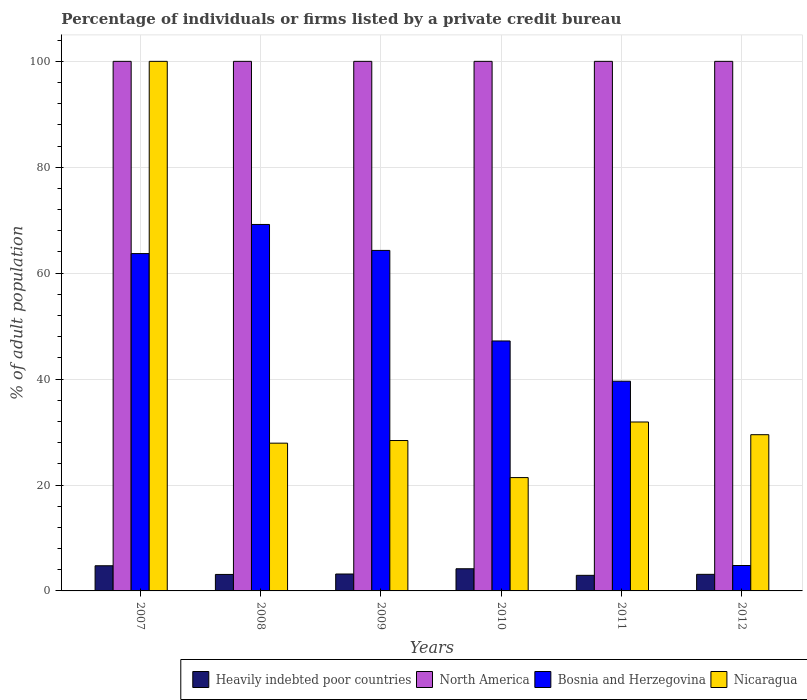Are the number of bars per tick equal to the number of legend labels?
Give a very brief answer. Yes. How many bars are there on the 6th tick from the left?
Your response must be concise. 4. How many bars are there on the 5th tick from the right?
Give a very brief answer. 4. What is the label of the 6th group of bars from the left?
Make the answer very short. 2012. What is the percentage of population listed by a private credit bureau in Bosnia and Herzegovina in 2011?
Your answer should be compact. 39.6. Across all years, what is the maximum percentage of population listed by a private credit bureau in North America?
Provide a succinct answer. 100. Across all years, what is the minimum percentage of population listed by a private credit bureau in North America?
Offer a very short reply. 100. In which year was the percentage of population listed by a private credit bureau in Bosnia and Herzegovina maximum?
Your response must be concise. 2008. What is the total percentage of population listed by a private credit bureau in Heavily indebted poor countries in the graph?
Make the answer very short. 21.32. What is the difference between the percentage of population listed by a private credit bureau in Bosnia and Herzegovina in 2007 and that in 2012?
Give a very brief answer. 58.9. What is the difference between the percentage of population listed by a private credit bureau in Heavily indebted poor countries in 2008 and the percentage of population listed by a private credit bureau in Bosnia and Herzegovina in 2009?
Make the answer very short. -61.19. What is the average percentage of population listed by a private credit bureau in Nicaragua per year?
Make the answer very short. 39.85. In the year 2009, what is the difference between the percentage of population listed by a private credit bureau in Bosnia and Herzegovina and percentage of population listed by a private credit bureau in North America?
Provide a short and direct response. -35.7. What is the ratio of the percentage of population listed by a private credit bureau in Heavily indebted poor countries in 2010 to that in 2011?
Offer a terse response. 1.42. Is the percentage of population listed by a private credit bureau in Heavily indebted poor countries in 2007 less than that in 2011?
Ensure brevity in your answer.  No. What is the difference between the highest and the second highest percentage of population listed by a private credit bureau in Nicaragua?
Your answer should be very brief. 68.1. What is the difference between the highest and the lowest percentage of population listed by a private credit bureau in Bosnia and Herzegovina?
Your answer should be very brief. 64.4. Is the sum of the percentage of population listed by a private credit bureau in Bosnia and Herzegovina in 2007 and 2010 greater than the maximum percentage of population listed by a private credit bureau in North America across all years?
Offer a terse response. Yes. Is it the case that in every year, the sum of the percentage of population listed by a private credit bureau in Nicaragua and percentage of population listed by a private credit bureau in North America is greater than the sum of percentage of population listed by a private credit bureau in Heavily indebted poor countries and percentage of population listed by a private credit bureau in Bosnia and Herzegovina?
Offer a very short reply. No. What does the 4th bar from the left in 2008 represents?
Offer a very short reply. Nicaragua. What does the 2nd bar from the right in 2010 represents?
Your answer should be very brief. Bosnia and Herzegovina. How many bars are there?
Keep it short and to the point. 24. Are all the bars in the graph horizontal?
Make the answer very short. No. How many years are there in the graph?
Provide a succinct answer. 6. What is the difference between two consecutive major ticks on the Y-axis?
Keep it short and to the point. 20. How many legend labels are there?
Your response must be concise. 4. How are the legend labels stacked?
Make the answer very short. Horizontal. What is the title of the graph?
Make the answer very short. Percentage of individuals or firms listed by a private credit bureau. What is the label or title of the X-axis?
Make the answer very short. Years. What is the label or title of the Y-axis?
Make the answer very short. % of adult population. What is the % of adult population in Heavily indebted poor countries in 2007?
Provide a short and direct response. 4.75. What is the % of adult population of Bosnia and Herzegovina in 2007?
Your response must be concise. 63.7. What is the % of adult population in Nicaragua in 2007?
Make the answer very short. 100. What is the % of adult population of Heavily indebted poor countries in 2008?
Ensure brevity in your answer.  3.11. What is the % of adult population of North America in 2008?
Make the answer very short. 100. What is the % of adult population of Bosnia and Herzegovina in 2008?
Offer a terse response. 69.2. What is the % of adult population of Nicaragua in 2008?
Make the answer very short. 27.9. What is the % of adult population in Heavily indebted poor countries in 2009?
Your response must be concise. 3.19. What is the % of adult population of North America in 2009?
Keep it short and to the point. 100. What is the % of adult population in Bosnia and Herzegovina in 2009?
Give a very brief answer. 64.3. What is the % of adult population in Nicaragua in 2009?
Ensure brevity in your answer.  28.4. What is the % of adult population of Heavily indebted poor countries in 2010?
Provide a short and direct response. 4.18. What is the % of adult population of Bosnia and Herzegovina in 2010?
Your answer should be compact. 47.2. What is the % of adult population in Nicaragua in 2010?
Provide a succinct answer. 21.4. What is the % of adult population of Heavily indebted poor countries in 2011?
Your answer should be very brief. 2.94. What is the % of adult population of North America in 2011?
Ensure brevity in your answer.  100. What is the % of adult population of Bosnia and Herzegovina in 2011?
Provide a succinct answer. 39.6. What is the % of adult population of Nicaragua in 2011?
Your response must be concise. 31.9. What is the % of adult population in Heavily indebted poor countries in 2012?
Provide a short and direct response. 3.13. What is the % of adult population in Bosnia and Herzegovina in 2012?
Give a very brief answer. 4.8. What is the % of adult population in Nicaragua in 2012?
Make the answer very short. 29.5. Across all years, what is the maximum % of adult population of Heavily indebted poor countries?
Keep it short and to the point. 4.75. Across all years, what is the maximum % of adult population in Bosnia and Herzegovina?
Offer a terse response. 69.2. Across all years, what is the maximum % of adult population in Nicaragua?
Your answer should be very brief. 100. Across all years, what is the minimum % of adult population in Heavily indebted poor countries?
Your response must be concise. 2.94. Across all years, what is the minimum % of adult population of Bosnia and Herzegovina?
Offer a very short reply. 4.8. Across all years, what is the minimum % of adult population of Nicaragua?
Offer a terse response. 21.4. What is the total % of adult population of Heavily indebted poor countries in the graph?
Make the answer very short. 21.32. What is the total % of adult population in North America in the graph?
Ensure brevity in your answer.  600. What is the total % of adult population of Bosnia and Herzegovina in the graph?
Provide a succinct answer. 288.8. What is the total % of adult population of Nicaragua in the graph?
Your answer should be compact. 239.1. What is the difference between the % of adult population of Heavily indebted poor countries in 2007 and that in 2008?
Make the answer very short. 1.64. What is the difference between the % of adult population of Bosnia and Herzegovina in 2007 and that in 2008?
Your response must be concise. -5.5. What is the difference between the % of adult population of Nicaragua in 2007 and that in 2008?
Keep it short and to the point. 72.1. What is the difference between the % of adult population in Heavily indebted poor countries in 2007 and that in 2009?
Your answer should be compact. 1.56. What is the difference between the % of adult population in Nicaragua in 2007 and that in 2009?
Your answer should be compact. 71.6. What is the difference between the % of adult population of Heavily indebted poor countries in 2007 and that in 2010?
Ensure brevity in your answer.  0.57. What is the difference between the % of adult population of North America in 2007 and that in 2010?
Provide a short and direct response. 0. What is the difference between the % of adult population in Bosnia and Herzegovina in 2007 and that in 2010?
Your answer should be very brief. 16.5. What is the difference between the % of adult population of Nicaragua in 2007 and that in 2010?
Your answer should be very brief. 78.6. What is the difference between the % of adult population in Heavily indebted poor countries in 2007 and that in 2011?
Offer a very short reply. 1.81. What is the difference between the % of adult population in North America in 2007 and that in 2011?
Give a very brief answer. 0. What is the difference between the % of adult population of Bosnia and Herzegovina in 2007 and that in 2011?
Offer a terse response. 24.1. What is the difference between the % of adult population of Nicaragua in 2007 and that in 2011?
Make the answer very short. 68.1. What is the difference between the % of adult population in Heavily indebted poor countries in 2007 and that in 2012?
Your response must be concise. 1.62. What is the difference between the % of adult population in Bosnia and Herzegovina in 2007 and that in 2012?
Your answer should be very brief. 58.9. What is the difference between the % of adult population of Nicaragua in 2007 and that in 2012?
Your answer should be compact. 70.5. What is the difference between the % of adult population in Heavily indebted poor countries in 2008 and that in 2009?
Provide a short and direct response. -0.08. What is the difference between the % of adult population in North America in 2008 and that in 2009?
Your answer should be very brief. 0. What is the difference between the % of adult population of Nicaragua in 2008 and that in 2009?
Give a very brief answer. -0.5. What is the difference between the % of adult population in Heavily indebted poor countries in 2008 and that in 2010?
Your answer should be very brief. -1.07. What is the difference between the % of adult population in Bosnia and Herzegovina in 2008 and that in 2010?
Keep it short and to the point. 22. What is the difference between the % of adult population in Heavily indebted poor countries in 2008 and that in 2011?
Provide a short and direct response. 0.17. What is the difference between the % of adult population in North America in 2008 and that in 2011?
Offer a very short reply. 0. What is the difference between the % of adult population of Bosnia and Herzegovina in 2008 and that in 2011?
Offer a very short reply. 29.6. What is the difference between the % of adult population of Nicaragua in 2008 and that in 2011?
Offer a terse response. -4. What is the difference between the % of adult population of Heavily indebted poor countries in 2008 and that in 2012?
Your answer should be very brief. -0.02. What is the difference between the % of adult population of North America in 2008 and that in 2012?
Your answer should be very brief. 0. What is the difference between the % of adult population in Bosnia and Herzegovina in 2008 and that in 2012?
Make the answer very short. 64.4. What is the difference between the % of adult population in Heavily indebted poor countries in 2009 and that in 2010?
Your answer should be compact. -0.99. What is the difference between the % of adult population of Bosnia and Herzegovina in 2009 and that in 2010?
Provide a short and direct response. 17.1. What is the difference between the % of adult population in Nicaragua in 2009 and that in 2010?
Your answer should be very brief. 7. What is the difference between the % of adult population in Heavily indebted poor countries in 2009 and that in 2011?
Offer a very short reply. 0.25. What is the difference between the % of adult population of Bosnia and Herzegovina in 2009 and that in 2011?
Your answer should be very brief. 24.7. What is the difference between the % of adult population in Heavily indebted poor countries in 2009 and that in 2012?
Give a very brief answer. 0.06. What is the difference between the % of adult population of Bosnia and Herzegovina in 2009 and that in 2012?
Ensure brevity in your answer.  59.5. What is the difference between the % of adult population in Nicaragua in 2009 and that in 2012?
Ensure brevity in your answer.  -1.1. What is the difference between the % of adult population of Heavily indebted poor countries in 2010 and that in 2011?
Offer a very short reply. 1.24. What is the difference between the % of adult population of North America in 2010 and that in 2011?
Make the answer very short. 0. What is the difference between the % of adult population in Nicaragua in 2010 and that in 2011?
Make the answer very short. -10.5. What is the difference between the % of adult population of Heavily indebted poor countries in 2010 and that in 2012?
Your answer should be very brief. 1.05. What is the difference between the % of adult population in Bosnia and Herzegovina in 2010 and that in 2012?
Make the answer very short. 42.4. What is the difference between the % of adult population of Heavily indebted poor countries in 2011 and that in 2012?
Give a very brief answer. -0.19. What is the difference between the % of adult population in Bosnia and Herzegovina in 2011 and that in 2012?
Your answer should be very brief. 34.8. What is the difference between the % of adult population in Nicaragua in 2011 and that in 2012?
Keep it short and to the point. 2.4. What is the difference between the % of adult population of Heavily indebted poor countries in 2007 and the % of adult population of North America in 2008?
Offer a terse response. -95.25. What is the difference between the % of adult population in Heavily indebted poor countries in 2007 and the % of adult population in Bosnia and Herzegovina in 2008?
Provide a succinct answer. -64.45. What is the difference between the % of adult population in Heavily indebted poor countries in 2007 and the % of adult population in Nicaragua in 2008?
Your response must be concise. -23.15. What is the difference between the % of adult population in North America in 2007 and the % of adult population in Bosnia and Herzegovina in 2008?
Offer a terse response. 30.8. What is the difference between the % of adult population in North America in 2007 and the % of adult population in Nicaragua in 2008?
Provide a succinct answer. 72.1. What is the difference between the % of adult population of Bosnia and Herzegovina in 2007 and the % of adult population of Nicaragua in 2008?
Make the answer very short. 35.8. What is the difference between the % of adult population of Heavily indebted poor countries in 2007 and the % of adult population of North America in 2009?
Give a very brief answer. -95.25. What is the difference between the % of adult population in Heavily indebted poor countries in 2007 and the % of adult population in Bosnia and Herzegovina in 2009?
Provide a short and direct response. -59.55. What is the difference between the % of adult population in Heavily indebted poor countries in 2007 and the % of adult population in Nicaragua in 2009?
Offer a terse response. -23.65. What is the difference between the % of adult population in North America in 2007 and the % of adult population in Bosnia and Herzegovina in 2009?
Your answer should be compact. 35.7. What is the difference between the % of adult population in North America in 2007 and the % of adult population in Nicaragua in 2009?
Your answer should be compact. 71.6. What is the difference between the % of adult population in Bosnia and Herzegovina in 2007 and the % of adult population in Nicaragua in 2009?
Your answer should be compact. 35.3. What is the difference between the % of adult population in Heavily indebted poor countries in 2007 and the % of adult population in North America in 2010?
Offer a very short reply. -95.25. What is the difference between the % of adult population in Heavily indebted poor countries in 2007 and the % of adult population in Bosnia and Herzegovina in 2010?
Provide a short and direct response. -42.45. What is the difference between the % of adult population of Heavily indebted poor countries in 2007 and the % of adult population of Nicaragua in 2010?
Provide a succinct answer. -16.65. What is the difference between the % of adult population in North America in 2007 and the % of adult population in Bosnia and Herzegovina in 2010?
Offer a terse response. 52.8. What is the difference between the % of adult population of North America in 2007 and the % of adult population of Nicaragua in 2010?
Ensure brevity in your answer.  78.6. What is the difference between the % of adult population of Bosnia and Herzegovina in 2007 and the % of adult population of Nicaragua in 2010?
Your answer should be compact. 42.3. What is the difference between the % of adult population in Heavily indebted poor countries in 2007 and the % of adult population in North America in 2011?
Provide a short and direct response. -95.25. What is the difference between the % of adult population in Heavily indebted poor countries in 2007 and the % of adult population in Bosnia and Herzegovina in 2011?
Your answer should be compact. -34.85. What is the difference between the % of adult population in Heavily indebted poor countries in 2007 and the % of adult population in Nicaragua in 2011?
Provide a succinct answer. -27.15. What is the difference between the % of adult population in North America in 2007 and the % of adult population in Bosnia and Herzegovina in 2011?
Give a very brief answer. 60.4. What is the difference between the % of adult population in North America in 2007 and the % of adult population in Nicaragua in 2011?
Ensure brevity in your answer.  68.1. What is the difference between the % of adult population in Bosnia and Herzegovina in 2007 and the % of adult population in Nicaragua in 2011?
Provide a succinct answer. 31.8. What is the difference between the % of adult population of Heavily indebted poor countries in 2007 and the % of adult population of North America in 2012?
Keep it short and to the point. -95.25. What is the difference between the % of adult population in Heavily indebted poor countries in 2007 and the % of adult population in Bosnia and Herzegovina in 2012?
Keep it short and to the point. -0.05. What is the difference between the % of adult population of Heavily indebted poor countries in 2007 and the % of adult population of Nicaragua in 2012?
Give a very brief answer. -24.75. What is the difference between the % of adult population of North America in 2007 and the % of adult population of Bosnia and Herzegovina in 2012?
Make the answer very short. 95.2. What is the difference between the % of adult population of North America in 2007 and the % of adult population of Nicaragua in 2012?
Provide a short and direct response. 70.5. What is the difference between the % of adult population in Bosnia and Herzegovina in 2007 and the % of adult population in Nicaragua in 2012?
Give a very brief answer. 34.2. What is the difference between the % of adult population in Heavily indebted poor countries in 2008 and the % of adult population in North America in 2009?
Your answer should be very brief. -96.89. What is the difference between the % of adult population of Heavily indebted poor countries in 2008 and the % of adult population of Bosnia and Herzegovina in 2009?
Provide a succinct answer. -61.19. What is the difference between the % of adult population in Heavily indebted poor countries in 2008 and the % of adult population in Nicaragua in 2009?
Provide a short and direct response. -25.29. What is the difference between the % of adult population of North America in 2008 and the % of adult population of Bosnia and Herzegovina in 2009?
Offer a very short reply. 35.7. What is the difference between the % of adult population of North America in 2008 and the % of adult population of Nicaragua in 2009?
Provide a succinct answer. 71.6. What is the difference between the % of adult population of Bosnia and Herzegovina in 2008 and the % of adult population of Nicaragua in 2009?
Offer a terse response. 40.8. What is the difference between the % of adult population in Heavily indebted poor countries in 2008 and the % of adult population in North America in 2010?
Keep it short and to the point. -96.89. What is the difference between the % of adult population in Heavily indebted poor countries in 2008 and the % of adult population in Bosnia and Herzegovina in 2010?
Offer a terse response. -44.09. What is the difference between the % of adult population of Heavily indebted poor countries in 2008 and the % of adult population of Nicaragua in 2010?
Your answer should be compact. -18.29. What is the difference between the % of adult population of North America in 2008 and the % of adult population of Bosnia and Herzegovina in 2010?
Your answer should be very brief. 52.8. What is the difference between the % of adult population in North America in 2008 and the % of adult population in Nicaragua in 2010?
Provide a succinct answer. 78.6. What is the difference between the % of adult population in Bosnia and Herzegovina in 2008 and the % of adult population in Nicaragua in 2010?
Your answer should be very brief. 47.8. What is the difference between the % of adult population of Heavily indebted poor countries in 2008 and the % of adult population of North America in 2011?
Your answer should be very brief. -96.89. What is the difference between the % of adult population of Heavily indebted poor countries in 2008 and the % of adult population of Bosnia and Herzegovina in 2011?
Make the answer very short. -36.49. What is the difference between the % of adult population of Heavily indebted poor countries in 2008 and the % of adult population of Nicaragua in 2011?
Offer a terse response. -28.79. What is the difference between the % of adult population in North America in 2008 and the % of adult population in Bosnia and Herzegovina in 2011?
Offer a terse response. 60.4. What is the difference between the % of adult population in North America in 2008 and the % of adult population in Nicaragua in 2011?
Your answer should be very brief. 68.1. What is the difference between the % of adult population in Bosnia and Herzegovina in 2008 and the % of adult population in Nicaragua in 2011?
Provide a succinct answer. 37.3. What is the difference between the % of adult population of Heavily indebted poor countries in 2008 and the % of adult population of North America in 2012?
Your answer should be compact. -96.89. What is the difference between the % of adult population in Heavily indebted poor countries in 2008 and the % of adult population in Bosnia and Herzegovina in 2012?
Ensure brevity in your answer.  -1.69. What is the difference between the % of adult population in Heavily indebted poor countries in 2008 and the % of adult population in Nicaragua in 2012?
Your response must be concise. -26.39. What is the difference between the % of adult population of North America in 2008 and the % of adult population of Bosnia and Herzegovina in 2012?
Provide a succinct answer. 95.2. What is the difference between the % of adult population in North America in 2008 and the % of adult population in Nicaragua in 2012?
Make the answer very short. 70.5. What is the difference between the % of adult population in Bosnia and Herzegovina in 2008 and the % of adult population in Nicaragua in 2012?
Keep it short and to the point. 39.7. What is the difference between the % of adult population in Heavily indebted poor countries in 2009 and the % of adult population in North America in 2010?
Ensure brevity in your answer.  -96.81. What is the difference between the % of adult population of Heavily indebted poor countries in 2009 and the % of adult population of Bosnia and Herzegovina in 2010?
Your answer should be compact. -44.01. What is the difference between the % of adult population of Heavily indebted poor countries in 2009 and the % of adult population of Nicaragua in 2010?
Make the answer very short. -18.21. What is the difference between the % of adult population of North America in 2009 and the % of adult population of Bosnia and Herzegovina in 2010?
Your response must be concise. 52.8. What is the difference between the % of adult population of North America in 2009 and the % of adult population of Nicaragua in 2010?
Offer a very short reply. 78.6. What is the difference between the % of adult population in Bosnia and Herzegovina in 2009 and the % of adult population in Nicaragua in 2010?
Offer a terse response. 42.9. What is the difference between the % of adult population in Heavily indebted poor countries in 2009 and the % of adult population in North America in 2011?
Your answer should be very brief. -96.81. What is the difference between the % of adult population in Heavily indebted poor countries in 2009 and the % of adult population in Bosnia and Herzegovina in 2011?
Your answer should be very brief. -36.41. What is the difference between the % of adult population of Heavily indebted poor countries in 2009 and the % of adult population of Nicaragua in 2011?
Give a very brief answer. -28.71. What is the difference between the % of adult population in North America in 2009 and the % of adult population in Bosnia and Herzegovina in 2011?
Your response must be concise. 60.4. What is the difference between the % of adult population in North America in 2009 and the % of adult population in Nicaragua in 2011?
Your answer should be compact. 68.1. What is the difference between the % of adult population of Bosnia and Herzegovina in 2009 and the % of adult population of Nicaragua in 2011?
Your response must be concise. 32.4. What is the difference between the % of adult population in Heavily indebted poor countries in 2009 and the % of adult population in North America in 2012?
Offer a very short reply. -96.81. What is the difference between the % of adult population of Heavily indebted poor countries in 2009 and the % of adult population of Bosnia and Herzegovina in 2012?
Your answer should be very brief. -1.61. What is the difference between the % of adult population in Heavily indebted poor countries in 2009 and the % of adult population in Nicaragua in 2012?
Your response must be concise. -26.31. What is the difference between the % of adult population in North America in 2009 and the % of adult population in Bosnia and Herzegovina in 2012?
Provide a short and direct response. 95.2. What is the difference between the % of adult population of North America in 2009 and the % of adult population of Nicaragua in 2012?
Your answer should be very brief. 70.5. What is the difference between the % of adult population of Bosnia and Herzegovina in 2009 and the % of adult population of Nicaragua in 2012?
Keep it short and to the point. 34.8. What is the difference between the % of adult population in Heavily indebted poor countries in 2010 and the % of adult population in North America in 2011?
Your answer should be compact. -95.82. What is the difference between the % of adult population in Heavily indebted poor countries in 2010 and the % of adult population in Bosnia and Herzegovina in 2011?
Offer a very short reply. -35.42. What is the difference between the % of adult population in Heavily indebted poor countries in 2010 and the % of adult population in Nicaragua in 2011?
Your response must be concise. -27.72. What is the difference between the % of adult population of North America in 2010 and the % of adult population of Bosnia and Herzegovina in 2011?
Your answer should be compact. 60.4. What is the difference between the % of adult population of North America in 2010 and the % of adult population of Nicaragua in 2011?
Offer a very short reply. 68.1. What is the difference between the % of adult population in Bosnia and Herzegovina in 2010 and the % of adult population in Nicaragua in 2011?
Offer a very short reply. 15.3. What is the difference between the % of adult population in Heavily indebted poor countries in 2010 and the % of adult population in North America in 2012?
Your answer should be very brief. -95.82. What is the difference between the % of adult population of Heavily indebted poor countries in 2010 and the % of adult population of Bosnia and Herzegovina in 2012?
Ensure brevity in your answer.  -0.62. What is the difference between the % of adult population in Heavily indebted poor countries in 2010 and the % of adult population in Nicaragua in 2012?
Your answer should be very brief. -25.32. What is the difference between the % of adult population in North America in 2010 and the % of adult population in Bosnia and Herzegovina in 2012?
Your answer should be compact. 95.2. What is the difference between the % of adult population of North America in 2010 and the % of adult population of Nicaragua in 2012?
Your response must be concise. 70.5. What is the difference between the % of adult population of Heavily indebted poor countries in 2011 and the % of adult population of North America in 2012?
Your answer should be very brief. -97.06. What is the difference between the % of adult population in Heavily indebted poor countries in 2011 and the % of adult population in Bosnia and Herzegovina in 2012?
Provide a short and direct response. -1.86. What is the difference between the % of adult population in Heavily indebted poor countries in 2011 and the % of adult population in Nicaragua in 2012?
Make the answer very short. -26.56. What is the difference between the % of adult population in North America in 2011 and the % of adult population in Bosnia and Herzegovina in 2012?
Give a very brief answer. 95.2. What is the difference between the % of adult population of North America in 2011 and the % of adult population of Nicaragua in 2012?
Give a very brief answer. 70.5. What is the difference between the % of adult population of Bosnia and Herzegovina in 2011 and the % of adult population of Nicaragua in 2012?
Offer a very short reply. 10.1. What is the average % of adult population in Heavily indebted poor countries per year?
Provide a succinct answer. 3.55. What is the average % of adult population of North America per year?
Your answer should be very brief. 100. What is the average % of adult population of Bosnia and Herzegovina per year?
Offer a very short reply. 48.13. What is the average % of adult population of Nicaragua per year?
Offer a very short reply. 39.85. In the year 2007, what is the difference between the % of adult population of Heavily indebted poor countries and % of adult population of North America?
Make the answer very short. -95.25. In the year 2007, what is the difference between the % of adult population in Heavily indebted poor countries and % of adult population in Bosnia and Herzegovina?
Provide a succinct answer. -58.95. In the year 2007, what is the difference between the % of adult population of Heavily indebted poor countries and % of adult population of Nicaragua?
Ensure brevity in your answer.  -95.25. In the year 2007, what is the difference between the % of adult population in North America and % of adult population in Bosnia and Herzegovina?
Offer a very short reply. 36.3. In the year 2007, what is the difference between the % of adult population of North America and % of adult population of Nicaragua?
Keep it short and to the point. 0. In the year 2007, what is the difference between the % of adult population of Bosnia and Herzegovina and % of adult population of Nicaragua?
Your answer should be compact. -36.3. In the year 2008, what is the difference between the % of adult population of Heavily indebted poor countries and % of adult population of North America?
Ensure brevity in your answer.  -96.89. In the year 2008, what is the difference between the % of adult population of Heavily indebted poor countries and % of adult population of Bosnia and Herzegovina?
Your answer should be compact. -66.09. In the year 2008, what is the difference between the % of adult population in Heavily indebted poor countries and % of adult population in Nicaragua?
Keep it short and to the point. -24.79. In the year 2008, what is the difference between the % of adult population of North America and % of adult population of Bosnia and Herzegovina?
Ensure brevity in your answer.  30.8. In the year 2008, what is the difference between the % of adult population of North America and % of adult population of Nicaragua?
Ensure brevity in your answer.  72.1. In the year 2008, what is the difference between the % of adult population of Bosnia and Herzegovina and % of adult population of Nicaragua?
Your response must be concise. 41.3. In the year 2009, what is the difference between the % of adult population of Heavily indebted poor countries and % of adult population of North America?
Provide a short and direct response. -96.81. In the year 2009, what is the difference between the % of adult population in Heavily indebted poor countries and % of adult population in Bosnia and Herzegovina?
Make the answer very short. -61.11. In the year 2009, what is the difference between the % of adult population in Heavily indebted poor countries and % of adult population in Nicaragua?
Ensure brevity in your answer.  -25.21. In the year 2009, what is the difference between the % of adult population in North America and % of adult population in Bosnia and Herzegovina?
Make the answer very short. 35.7. In the year 2009, what is the difference between the % of adult population of North America and % of adult population of Nicaragua?
Provide a succinct answer. 71.6. In the year 2009, what is the difference between the % of adult population in Bosnia and Herzegovina and % of adult population in Nicaragua?
Your response must be concise. 35.9. In the year 2010, what is the difference between the % of adult population in Heavily indebted poor countries and % of adult population in North America?
Ensure brevity in your answer.  -95.82. In the year 2010, what is the difference between the % of adult population of Heavily indebted poor countries and % of adult population of Bosnia and Herzegovina?
Offer a very short reply. -43.02. In the year 2010, what is the difference between the % of adult population in Heavily indebted poor countries and % of adult population in Nicaragua?
Your response must be concise. -17.22. In the year 2010, what is the difference between the % of adult population in North America and % of adult population in Bosnia and Herzegovina?
Give a very brief answer. 52.8. In the year 2010, what is the difference between the % of adult population in North America and % of adult population in Nicaragua?
Provide a succinct answer. 78.6. In the year 2010, what is the difference between the % of adult population in Bosnia and Herzegovina and % of adult population in Nicaragua?
Keep it short and to the point. 25.8. In the year 2011, what is the difference between the % of adult population of Heavily indebted poor countries and % of adult population of North America?
Ensure brevity in your answer.  -97.06. In the year 2011, what is the difference between the % of adult population in Heavily indebted poor countries and % of adult population in Bosnia and Herzegovina?
Make the answer very short. -36.66. In the year 2011, what is the difference between the % of adult population in Heavily indebted poor countries and % of adult population in Nicaragua?
Make the answer very short. -28.96. In the year 2011, what is the difference between the % of adult population of North America and % of adult population of Bosnia and Herzegovina?
Ensure brevity in your answer.  60.4. In the year 2011, what is the difference between the % of adult population in North America and % of adult population in Nicaragua?
Your answer should be compact. 68.1. In the year 2011, what is the difference between the % of adult population in Bosnia and Herzegovina and % of adult population in Nicaragua?
Keep it short and to the point. 7.7. In the year 2012, what is the difference between the % of adult population in Heavily indebted poor countries and % of adult population in North America?
Ensure brevity in your answer.  -96.87. In the year 2012, what is the difference between the % of adult population of Heavily indebted poor countries and % of adult population of Bosnia and Herzegovina?
Provide a short and direct response. -1.67. In the year 2012, what is the difference between the % of adult population of Heavily indebted poor countries and % of adult population of Nicaragua?
Offer a terse response. -26.37. In the year 2012, what is the difference between the % of adult population of North America and % of adult population of Bosnia and Herzegovina?
Give a very brief answer. 95.2. In the year 2012, what is the difference between the % of adult population of North America and % of adult population of Nicaragua?
Ensure brevity in your answer.  70.5. In the year 2012, what is the difference between the % of adult population in Bosnia and Herzegovina and % of adult population in Nicaragua?
Offer a very short reply. -24.7. What is the ratio of the % of adult population in Heavily indebted poor countries in 2007 to that in 2008?
Keep it short and to the point. 1.53. What is the ratio of the % of adult population of Bosnia and Herzegovina in 2007 to that in 2008?
Your answer should be very brief. 0.92. What is the ratio of the % of adult population of Nicaragua in 2007 to that in 2008?
Offer a terse response. 3.58. What is the ratio of the % of adult population of Heavily indebted poor countries in 2007 to that in 2009?
Provide a short and direct response. 1.49. What is the ratio of the % of adult population of Nicaragua in 2007 to that in 2009?
Provide a succinct answer. 3.52. What is the ratio of the % of adult population in Heavily indebted poor countries in 2007 to that in 2010?
Your answer should be compact. 1.14. What is the ratio of the % of adult population of Bosnia and Herzegovina in 2007 to that in 2010?
Make the answer very short. 1.35. What is the ratio of the % of adult population of Nicaragua in 2007 to that in 2010?
Keep it short and to the point. 4.67. What is the ratio of the % of adult population of Heavily indebted poor countries in 2007 to that in 2011?
Your answer should be very brief. 1.62. What is the ratio of the % of adult population of Bosnia and Herzegovina in 2007 to that in 2011?
Ensure brevity in your answer.  1.61. What is the ratio of the % of adult population in Nicaragua in 2007 to that in 2011?
Provide a short and direct response. 3.13. What is the ratio of the % of adult population in Heavily indebted poor countries in 2007 to that in 2012?
Ensure brevity in your answer.  1.52. What is the ratio of the % of adult population of North America in 2007 to that in 2012?
Keep it short and to the point. 1. What is the ratio of the % of adult population of Bosnia and Herzegovina in 2007 to that in 2012?
Make the answer very short. 13.27. What is the ratio of the % of adult population in Nicaragua in 2007 to that in 2012?
Offer a very short reply. 3.39. What is the ratio of the % of adult population of Heavily indebted poor countries in 2008 to that in 2009?
Give a very brief answer. 0.97. What is the ratio of the % of adult population of North America in 2008 to that in 2009?
Keep it short and to the point. 1. What is the ratio of the % of adult population in Bosnia and Herzegovina in 2008 to that in 2009?
Make the answer very short. 1.08. What is the ratio of the % of adult population in Nicaragua in 2008 to that in 2009?
Provide a succinct answer. 0.98. What is the ratio of the % of adult population of Heavily indebted poor countries in 2008 to that in 2010?
Make the answer very short. 0.74. What is the ratio of the % of adult population of Bosnia and Herzegovina in 2008 to that in 2010?
Ensure brevity in your answer.  1.47. What is the ratio of the % of adult population in Nicaragua in 2008 to that in 2010?
Offer a terse response. 1.3. What is the ratio of the % of adult population in Heavily indebted poor countries in 2008 to that in 2011?
Provide a short and direct response. 1.06. What is the ratio of the % of adult population of North America in 2008 to that in 2011?
Ensure brevity in your answer.  1. What is the ratio of the % of adult population of Bosnia and Herzegovina in 2008 to that in 2011?
Provide a short and direct response. 1.75. What is the ratio of the % of adult population in Nicaragua in 2008 to that in 2011?
Keep it short and to the point. 0.87. What is the ratio of the % of adult population of Bosnia and Herzegovina in 2008 to that in 2012?
Provide a short and direct response. 14.42. What is the ratio of the % of adult population of Nicaragua in 2008 to that in 2012?
Give a very brief answer. 0.95. What is the ratio of the % of adult population in Heavily indebted poor countries in 2009 to that in 2010?
Make the answer very short. 0.76. What is the ratio of the % of adult population in North America in 2009 to that in 2010?
Give a very brief answer. 1. What is the ratio of the % of adult population in Bosnia and Herzegovina in 2009 to that in 2010?
Provide a short and direct response. 1.36. What is the ratio of the % of adult population in Nicaragua in 2009 to that in 2010?
Offer a terse response. 1.33. What is the ratio of the % of adult population of Heavily indebted poor countries in 2009 to that in 2011?
Make the answer very short. 1.09. What is the ratio of the % of adult population of Bosnia and Herzegovina in 2009 to that in 2011?
Your response must be concise. 1.62. What is the ratio of the % of adult population of Nicaragua in 2009 to that in 2011?
Make the answer very short. 0.89. What is the ratio of the % of adult population of Heavily indebted poor countries in 2009 to that in 2012?
Make the answer very short. 1.02. What is the ratio of the % of adult population of North America in 2009 to that in 2012?
Your answer should be very brief. 1. What is the ratio of the % of adult population in Bosnia and Herzegovina in 2009 to that in 2012?
Your answer should be very brief. 13.4. What is the ratio of the % of adult population in Nicaragua in 2009 to that in 2012?
Your answer should be very brief. 0.96. What is the ratio of the % of adult population in Heavily indebted poor countries in 2010 to that in 2011?
Your response must be concise. 1.42. What is the ratio of the % of adult population in Bosnia and Herzegovina in 2010 to that in 2011?
Offer a terse response. 1.19. What is the ratio of the % of adult population in Nicaragua in 2010 to that in 2011?
Give a very brief answer. 0.67. What is the ratio of the % of adult population in Heavily indebted poor countries in 2010 to that in 2012?
Provide a succinct answer. 1.34. What is the ratio of the % of adult population in North America in 2010 to that in 2012?
Ensure brevity in your answer.  1. What is the ratio of the % of adult population of Bosnia and Herzegovina in 2010 to that in 2012?
Your answer should be very brief. 9.83. What is the ratio of the % of adult population of Nicaragua in 2010 to that in 2012?
Ensure brevity in your answer.  0.73. What is the ratio of the % of adult population in Heavily indebted poor countries in 2011 to that in 2012?
Your response must be concise. 0.94. What is the ratio of the % of adult population in Bosnia and Herzegovina in 2011 to that in 2012?
Your answer should be compact. 8.25. What is the ratio of the % of adult population in Nicaragua in 2011 to that in 2012?
Make the answer very short. 1.08. What is the difference between the highest and the second highest % of adult population in Heavily indebted poor countries?
Give a very brief answer. 0.57. What is the difference between the highest and the second highest % of adult population in Bosnia and Herzegovina?
Offer a very short reply. 4.9. What is the difference between the highest and the second highest % of adult population in Nicaragua?
Provide a succinct answer. 68.1. What is the difference between the highest and the lowest % of adult population of Heavily indebted poor countries?
Keep it short and to the point. 1.81. What is the difference between the highest and the lowest % of adult population in North America?
Your answer should be compact. 0. What is the difference between the highest and the lowest % of adult population of Bosnia and Herzegovina?
Your answer should be very brief. 64.4. What is the difference between the highest and the lowest % of adult population of Nicaragua?
Keep it short and to the point. 78.6. 